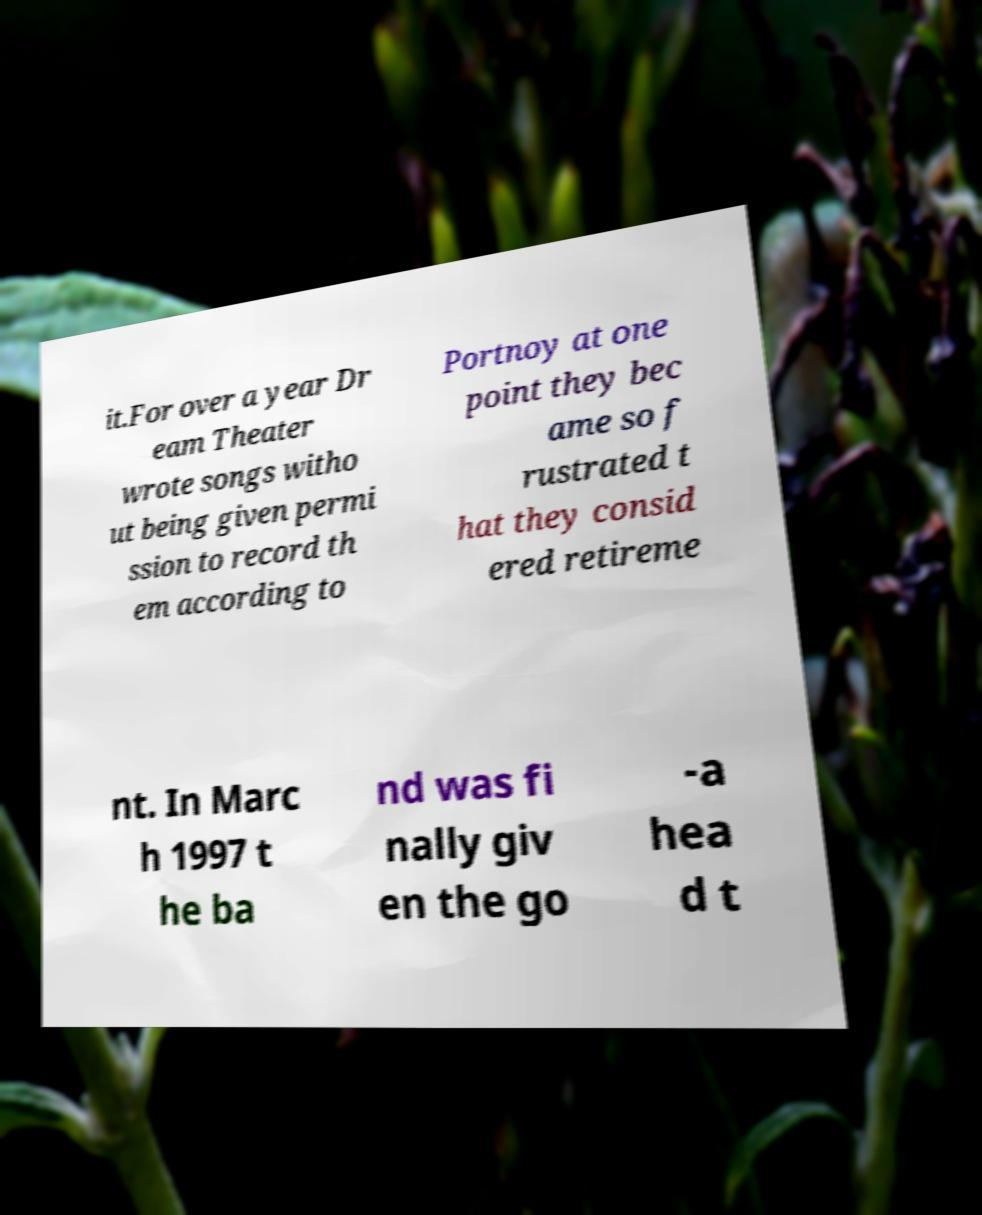Could you extract and type out the text from this image? it.For over a year Dr eam Theater wrote songs witho ut being given permi ssion to record th em according to Portnoy at one point they bec ame so f rustrated t hat they consid ered retireme nt. In Marc h 1997 t he ba nd was fi nally giv en the go -a hea d t 